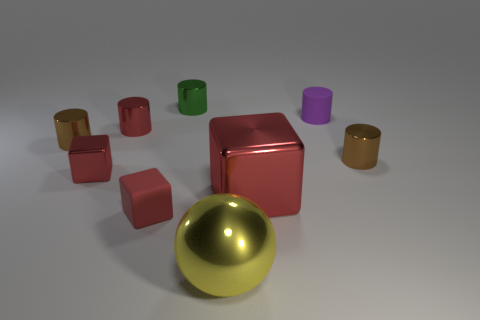Subtract 3 cylinders. How many cylinders are left? 2 Subtract all red metal cubes. How many cubes are left? 1 Add 1 red rubber things. How many objects exist? 10 Subtract all green cylinders. How many cylinders are left? 4 Subtract all blue cylinders. Subtract all brown cubes. How many cylinders are left? 5 Subtract all balls. How many objects are left? 8 Subtract all purple cylinders. Subtract all red matte blocks. How many objects are left? 7 Add 3 small brown metallic cylinders. How many small brown metallic cylinders are left? 5 Add 7 tiny red things. How many tiny red things exist? 10 Subtract 0 purple cubes. How many objects are left? 9 